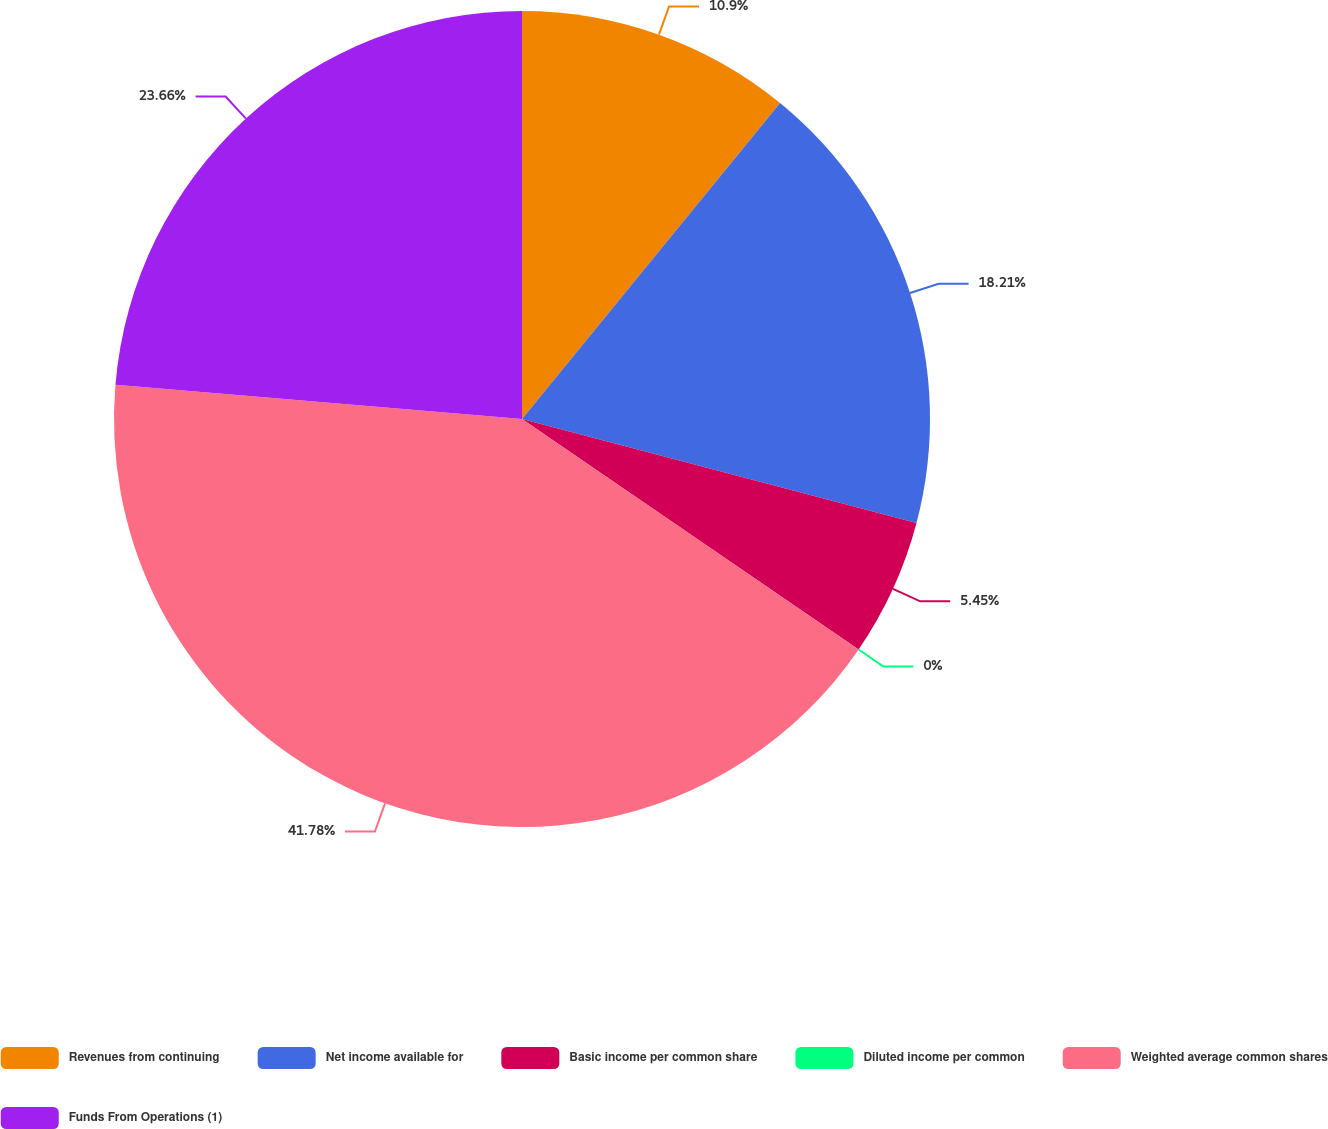Convert chart to OTSL. <chart><loc_0><loc_0><loc_500><loc_500><pie_chart><fcel>Revenues from continuing<fcel>Net income available for<fcel>Basic income per common share<fcel>Diluted income per common<fcel>Weighted average common shares<fcel>Funds From Operations (1)<nl><fcel>10.9%<fcel>18.21%<fcel>5.45%<fcel>0.0%<fcel>41.79%<fcel>23.66%<nl></chart> 